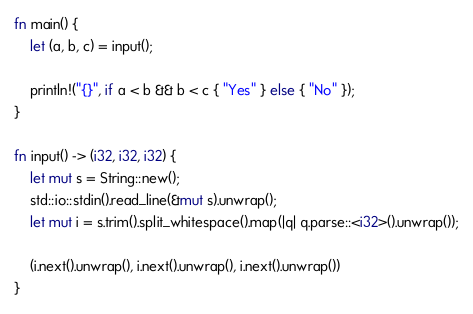Convert code to text. <code><loc_0><loc_0><loc_500><loc_500><_Rust_>fn main() {
    let (a, b, c) = input();

    println!("{}", if a < b && b < c { "Yes" } else { "No" });
}

fn input() -> (i32, i32, i32) {
    let mut s = String::new();
    std::io::stdin().read_line(&mut s).unwrap();
    let mut i = s.trim().split_whitespace().map(|q| q.parse::<i32>().unwrap());

    (i.next().unwrap(), i.next().unwrap(), i.next().unwrap())
}

</code> 